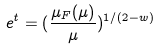<formula> <loc_0><loc_0><loc_500><loc_500>e ^ { t } = ( \frac { \mu _ { F } ( \mu ) } { \mu } ) ^ { 1 / ( 2 - w ) }</formula> 